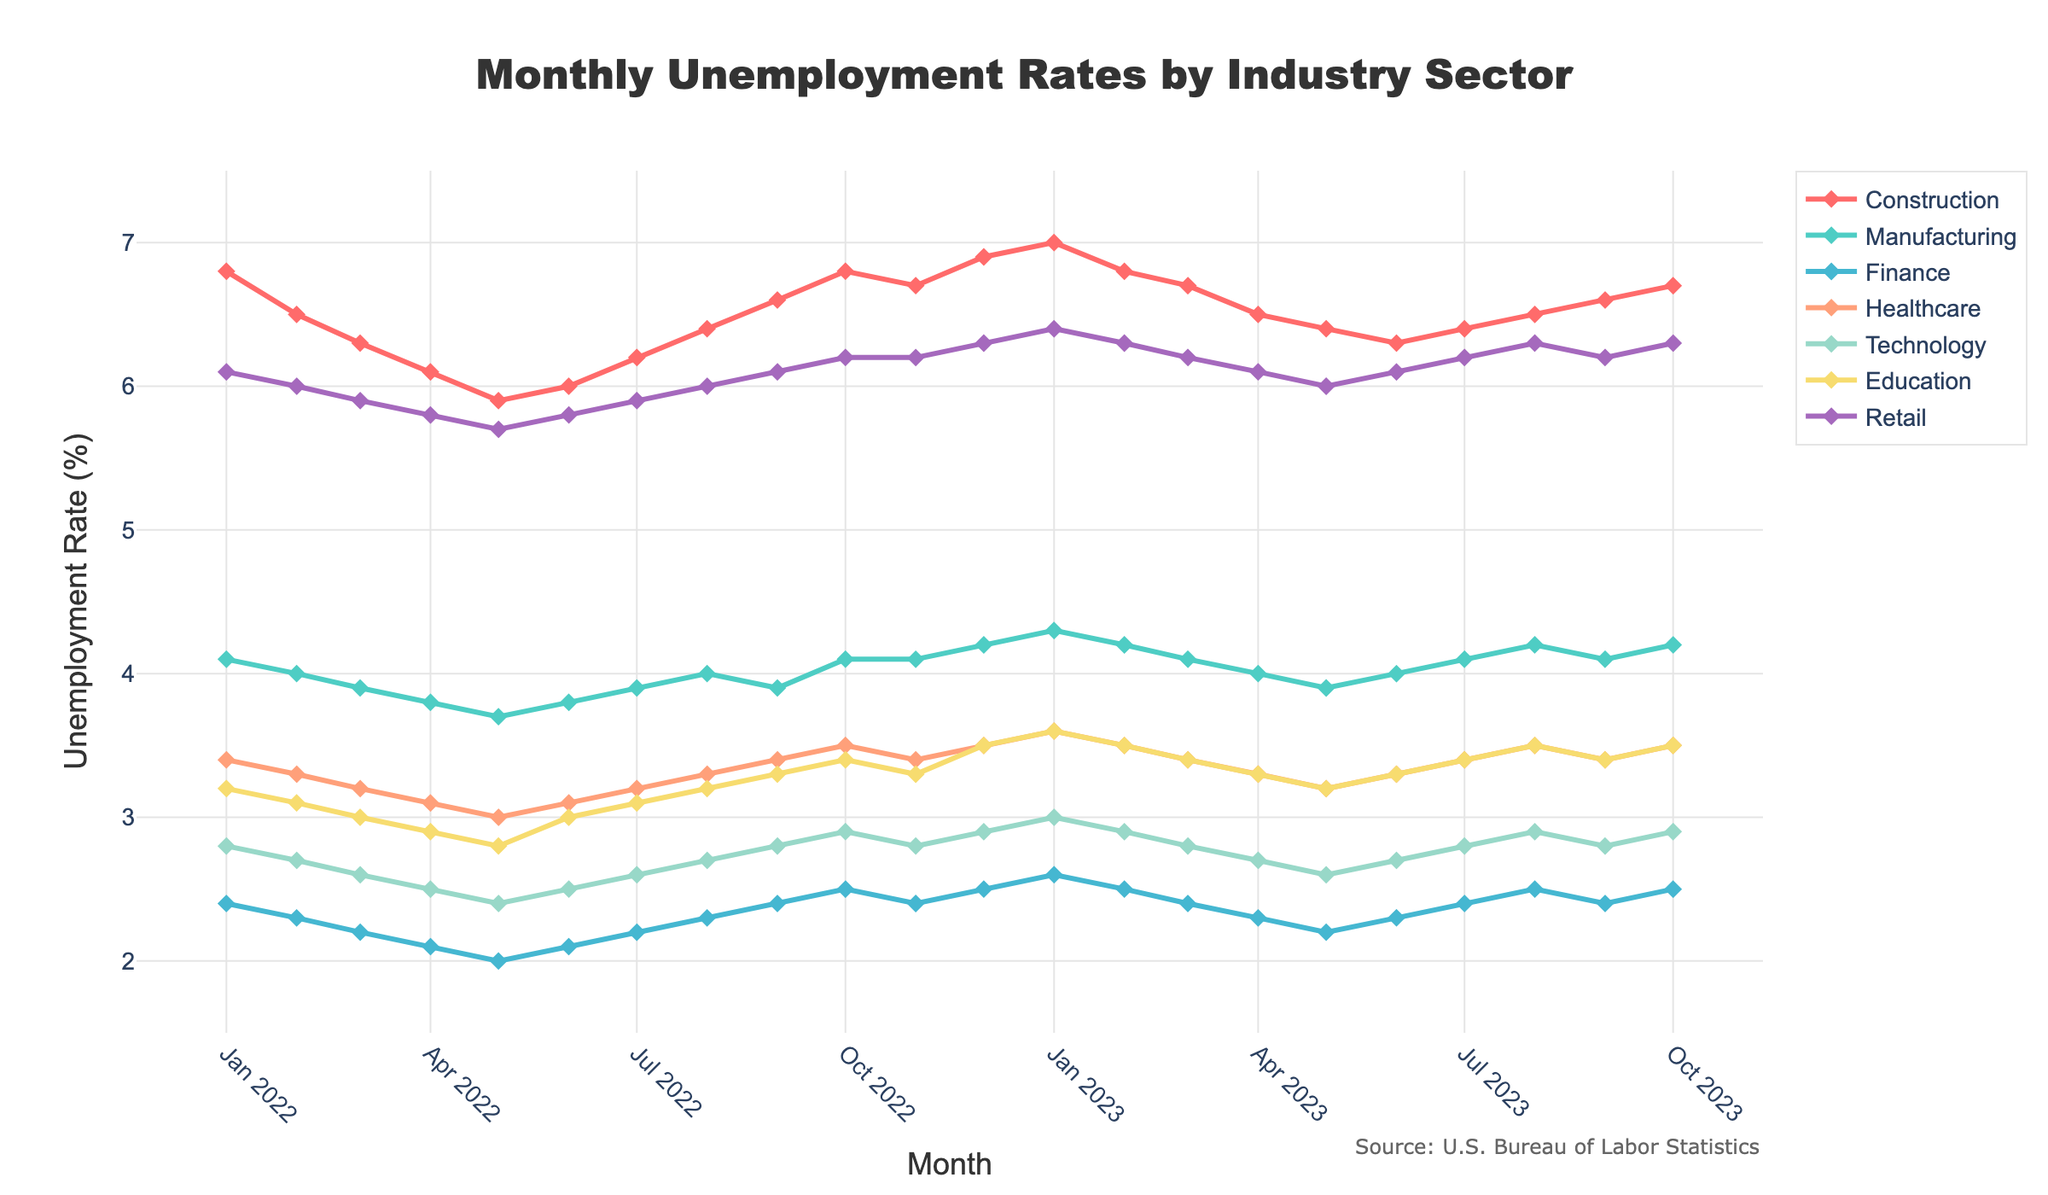How many industry sectors are shown in the plot? Count the number of sectors listed in the legend of the plot.
Answer: 7 What is the unemployment rate for the Construction sector in January 2022? Locate the January 2022 data point for the Construction sector on the plot, which corresponds to the y-axis value.
Answer: 6.8% Which sector had the highest unemployment rate in January 2022? Compare the y-axis values of all sectors for January 2022 and identify the sector with the highest value.
Answer: Construction How did the unemployment rate in the Healthcare sector change from January 2022 to January 2023? Find the y-axis values for the Healthcare sector in January 2022 and January 2023, then calculate the difference.
Answer: Increased by 0.2% Which two sectors experienced the largest increase in unemployment rate from May 2022 to January 2023? Identify the y-axis values of all sectors in May 2022 and January 2023, calculate the differences, and compare to determine the largest increases.
Answer: Construction and Technology What is the average unemployment rate in the Technology sector over the entire period? Add the y-axis values for each month in the Technology sector and then divide by the number of months.
Answer: 2.8% Which months have the highest and lowest overall unemployment rates across all sectors? For each month, sum the y-axis values of all sectors and identify the months with the highest and lowest sums.
Answer: Highest: January 2023, Lowest: May 2022 Was there any sector with a consistent trend (either increasing or decreasing) over the entire period? Analyze the time series line of each sector and identify if any have a consistent upward or downward trend from the start to end of the time period.
Answer: No, all sectors had fluctuations How does the unemployment rate in the Retail sector in October 2023 compare to the same month the previous year? Locate the y-axis values for the Retail sector in October 2022 and October 2023 and then compare them.
Answer: Same (6.2%) In which month did the Manufacturing sector experience its highest unemployment rate, and what was the rate? Identify the peak data point for the Manufacturing sector on the plot and note the corresponding month and y-axis value.
Answer: January 2023, 4.3% 